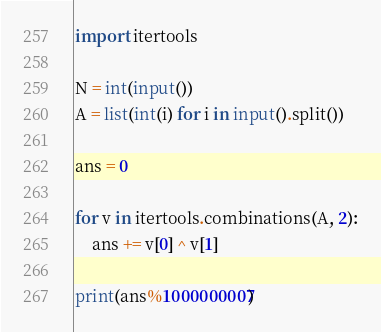<code> <loc_0><loc_0><loc_500><loc_500><_Python_>import itertools

N = int(input())
A = list(int(i) for i in input().split())

ans = 0

for v in itertools.combinations(A, 2):
    ans += v[0] ^ v[1]
    
print(ans%1000000007)</code> 